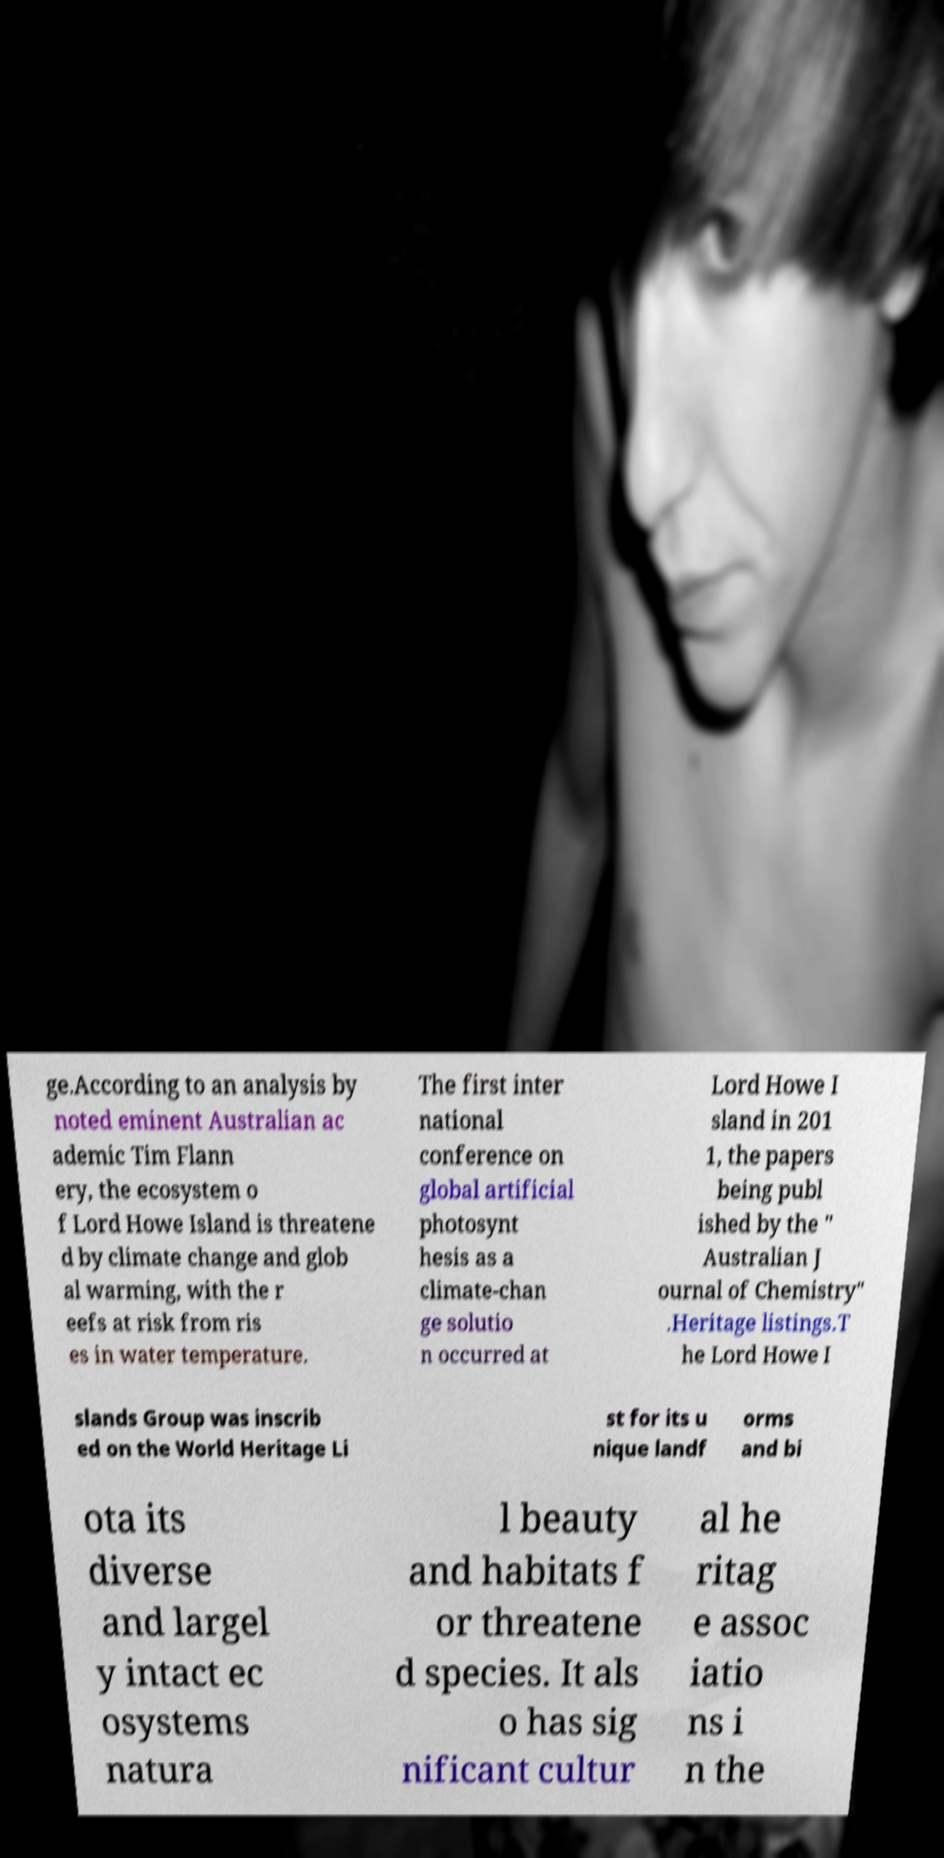I need the written content from this picture converted into text. Can you do that? ge.According to an analysis by noted eminent Australian ac ademic Tim Flann ery, the ecosystem o f Lord Howe Island is threatene d by climate change and glob al warming, with the r eefs at risk from ris es in water temperature. The first inter national conference on global artificial photosynt hesis as a climate-chan ge solutio n occurred at Lord Howe I sland in 201 1, the papers being publ ished by the " Australian J ournal of Chemistry" .Heritage listings.T he Lord Howe I slands Group was inscrib ed on the World Heritage Li st for its u nique landf orms and bi ota its diverse and largel y intact ec osystems natura l beauty and habitats f or threatene d species. It als o has sig nificant cultur al he ritag e assoc iatio ns i n the 